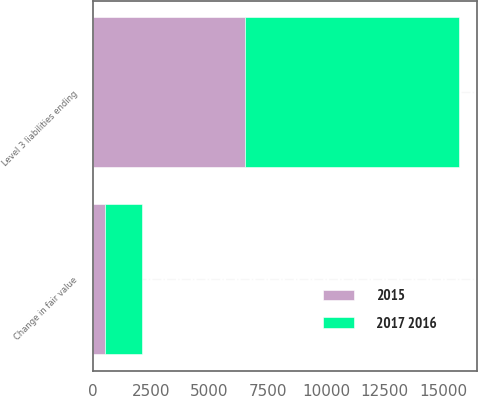<chart> <loc_0><loc_0><loc_500><loc_500><stacked_bar_chart><ecel><fcel>Change in fair value<fcel>Level 3 liabilities ending<nl><fcel>2017 2016<fcel>1590<fcel>9153<nl><fcel>2015<fcel>510<fcel>6510<nl></chart> 